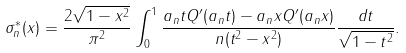<formula> <loc_0><loc_0><loc_500><loc_500>\sigma _ { n } ^ { * } ( x ) = \frac { 2 \sqrt { 1 - x ^ { 2 } } } { \pi ^ { 2 } } \int _ { 0 } ^ { 1 } \frac { a _ { n } t Q ^ { \prime } ( a _ { n } t ) - a _ { n } x Q ^ { \prime } ( a _ { n } x ) } { n ( t ^ { 2 } - x ^ { 2 } ) } \frac { d t } { \sqrt { 1 - t ^ { 2 } } } .</formula> 